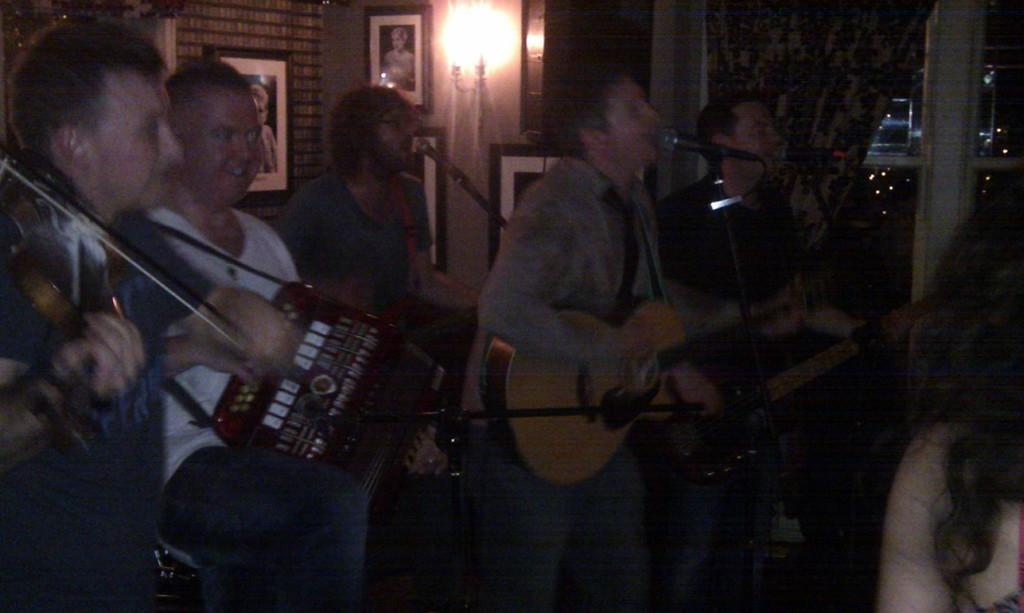Who or what can be seen in the image? There are people in the image. What are the people doing in the image? The people are standing and playing guitar in their hands. What type of engine can be seen in the image? There is no engine present in the image; it features people playing guitar. Is there any popcorn visible in the image? There is no popcorn present in the image. 